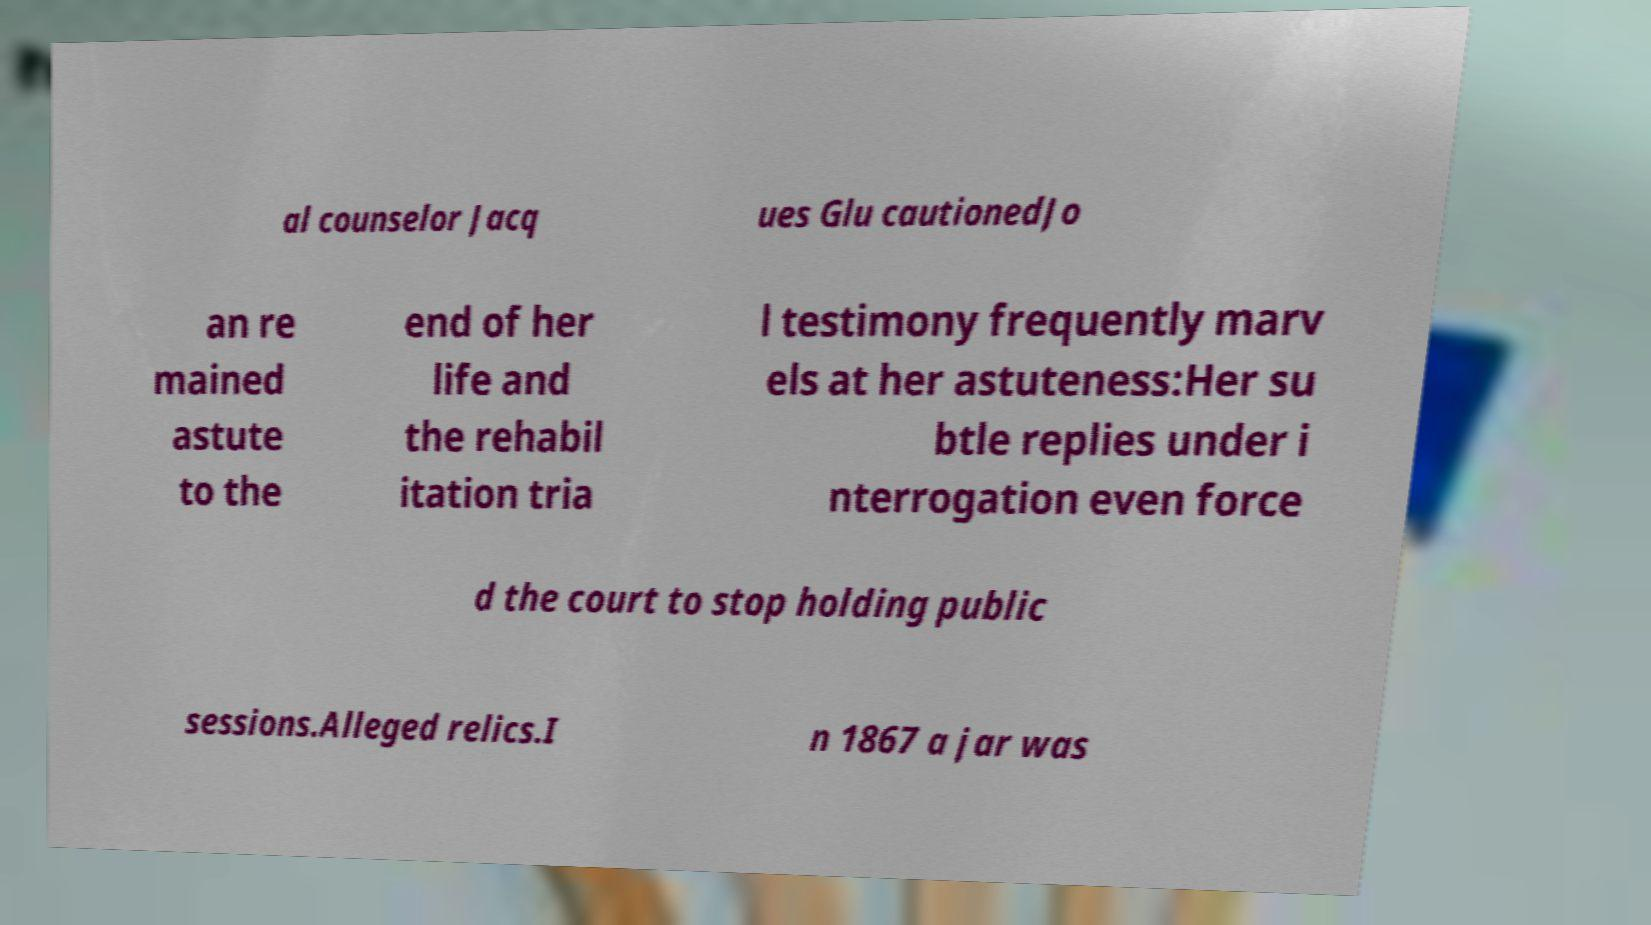What messages or text are displayed in this image? I need them in a readable, typed format. al counselor Jacq ues Glu cautionedJo an re mained astute to the end of her life and the rehabil itation tria l testimony frequently marv els at her astuteness:Her su btle replies under i nterrogation even force d the court to stop holding public sessions.Alleged relics.I n 1867 a jar was 